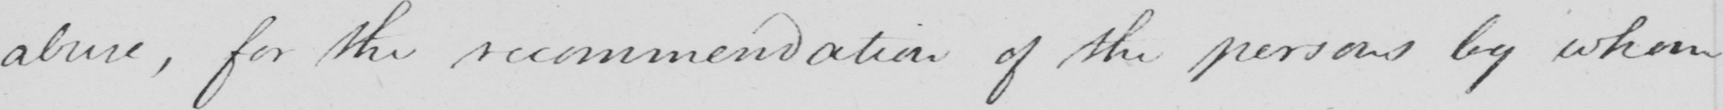Please transcribe the handwritten text in this image. abuse , for the recommendation of the persons by whom 